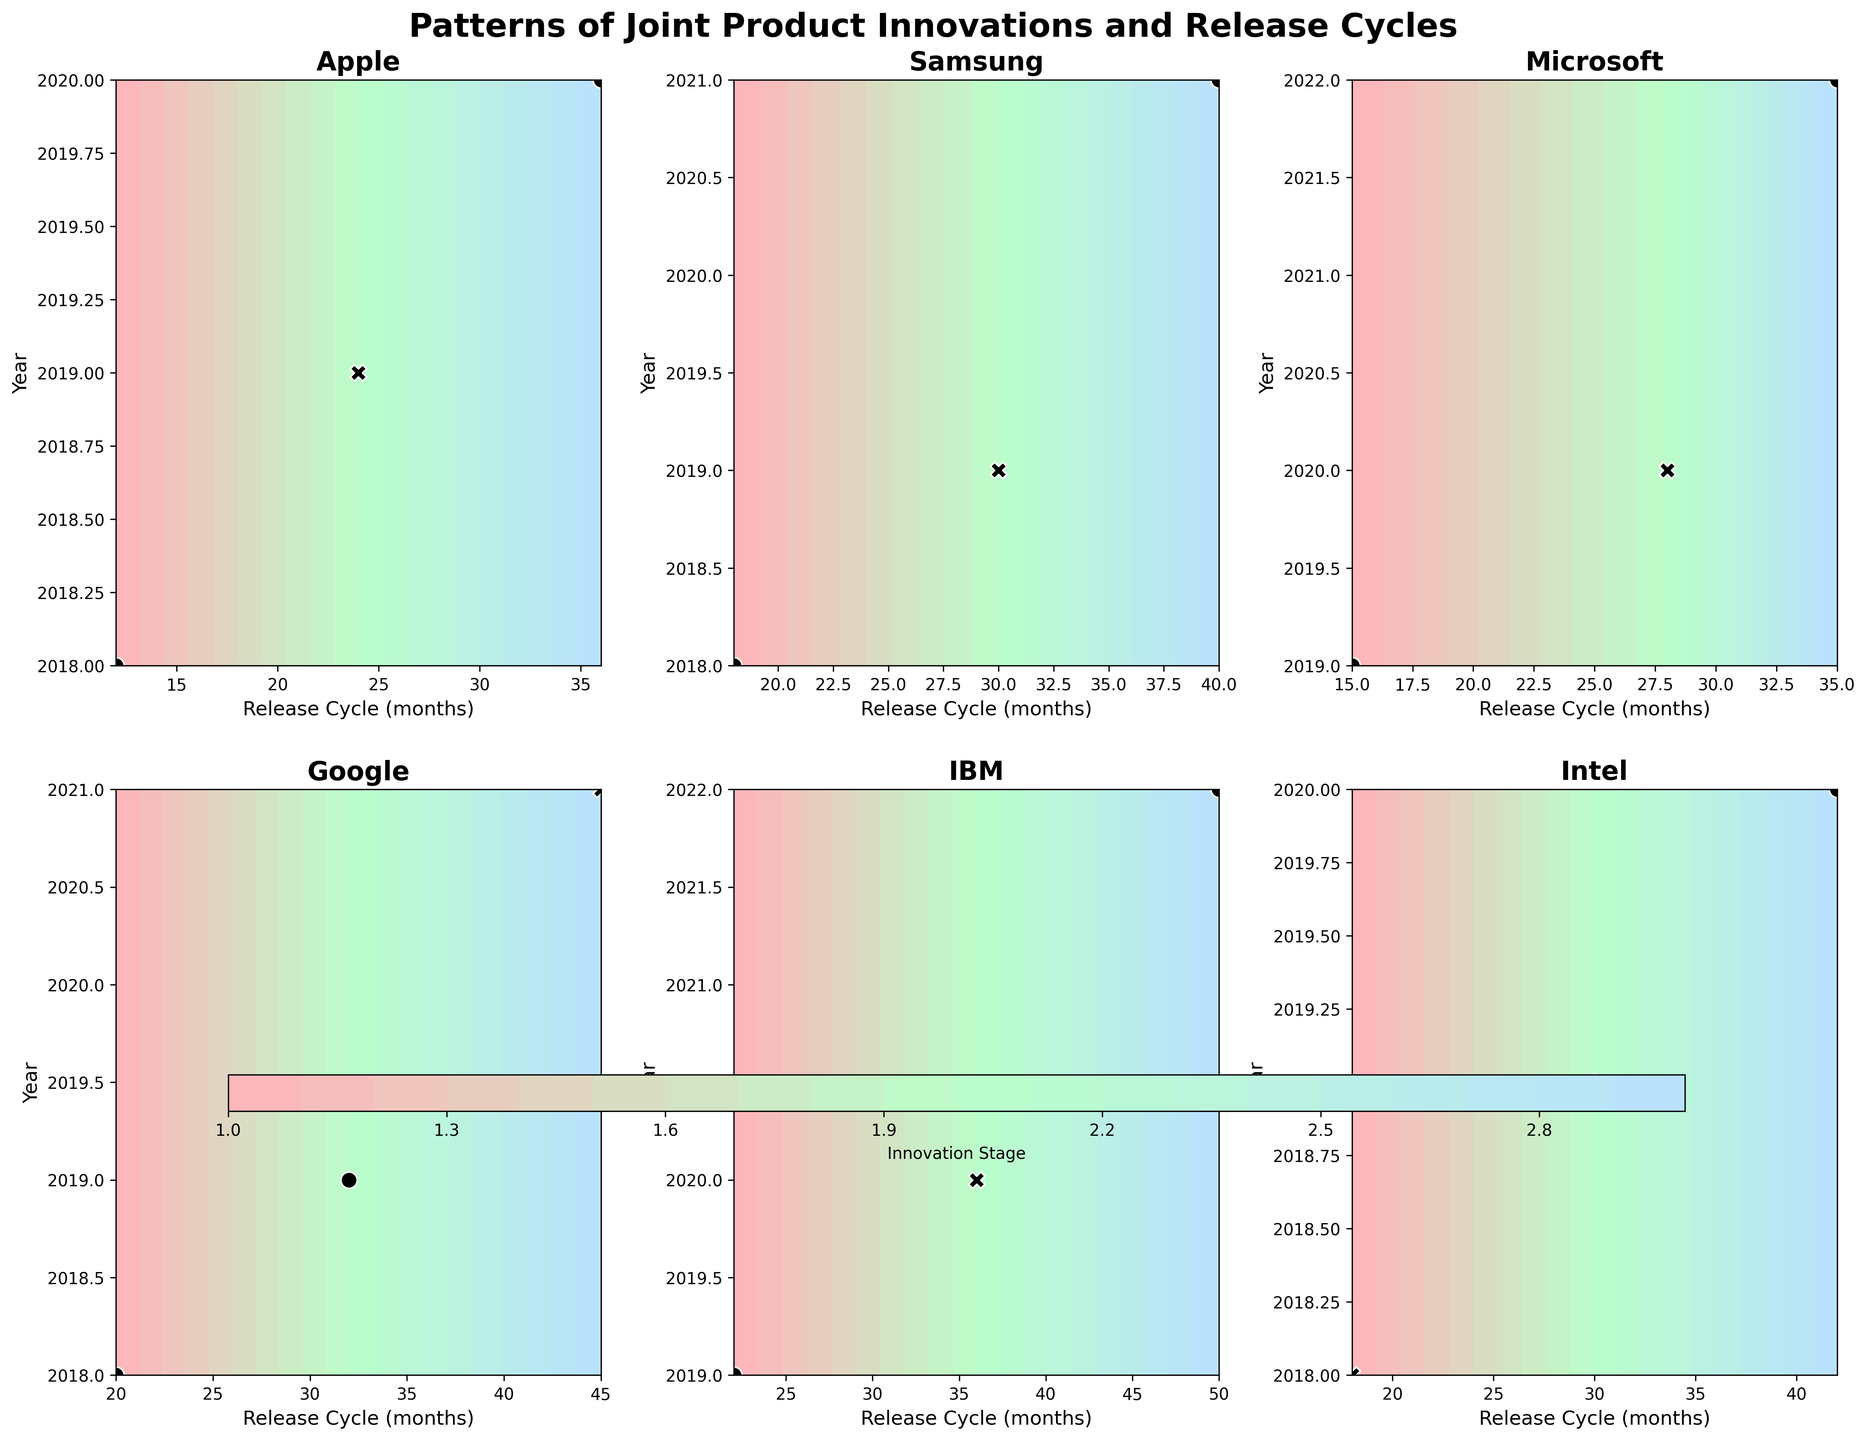What is the title of the figure? The title is displayed at the top center of the figure.
Answer: Patterns of Joint Product Innovations and Release Cycles Which company has the latest year for its Innovation Stage 3? By looking at the Y-axis values for each company subplot, we can see the year for Innovation Stage 3 for each company. IBM has the latest year, which is 2022.
Answer: IBM Which company has the most consistent (similar) Release Cycles for their Innovation Stages? By comparing the Release Cycles (X-axis) for each company's Innovation Stages, Apple has the most consistent with 12, 24, and 36 months.
Answer: Apple How many collaborative efforts are marked for Google across the years? The plot shows markers; circles represent collaborative efforts. Count the circles in Google's subplot. Google has two collaborative efforts.
Answer: 2 In which year did IBM have the most extended Release Cycle, and what was the duration? Examine the Y-axis against the X-axis in IBM's subplot. The year is 2022, and the Release Cycle is 50 months.
Answer: 2022, 50 months Does Samsung have more collaborative efforts in earlier years or later years? By examining the markers in Samsung's subplot, we see circles in earlier years 2018 and 2021, suggesting earlier years have more collaborative efforts.
Answer: Earlier years Among all the companies, which has the minimum Release Cycle for Innovation Stage 2, and what is the duration? Compare the X-axis values of the second Innovation Stage (S2) for all subplots. Apple has the shortest Release Cycle for S2 with 24 months.
Answer: Apple, 24 months Compare the Release Cycles of Microsoft and Intel's Innovation Stages. Which company shows a larger increase across the stages? Microsoft: 15 to 28 to 35 months (increase of 20 months). Intel: 18 to 30 to 42 months (increase of 24 months). Intel shows a larger increase.
Answer: Intel Which year shows the maximum number of collaborative efforts across all companies? By tallying the circles year by year across all subplots, 2019 shows the maximum collaborative efforts with circles in Google, IBM, Intel, and Microsoft subplots.
Answer: 2019 Is there a correlation between higher innovation stages and longer release cycles for Apple? Apple's subplot shows Innovation Stage 1 at 12 months, Stage 2 at 24 months, and Stage 3 at 36 months, indicating a correlation between higher stages and longer release cycles.
Answer: Yes 